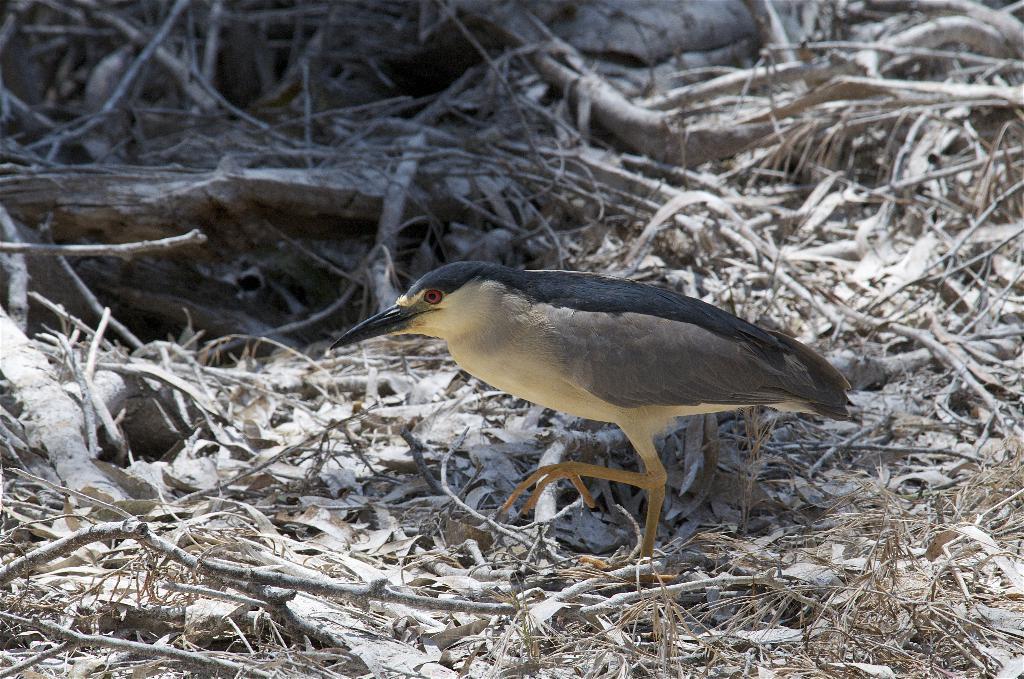Can you describe this image briefly? There is a bird walking on the ground. On the ground there are sticks and dried leaves. 